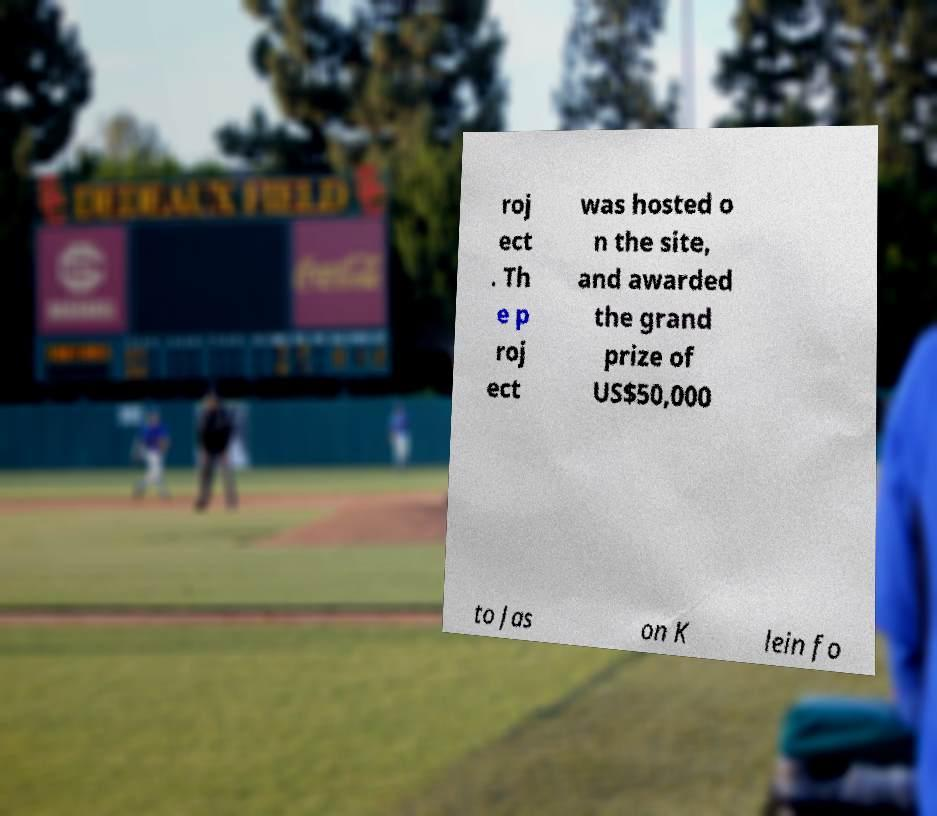Please identify and transcribe the text found in this image. roj ect . Th e p roj ect was hosted o n the site, and awarded the grand prize of US$50,000 to Jas on K lein fo 